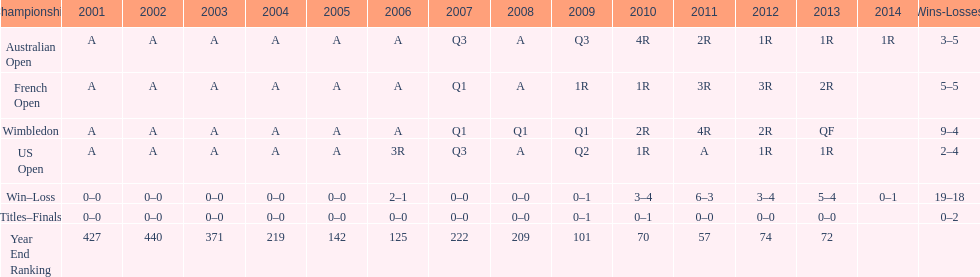What tournament has 5-5 as it's "w-l" record? French Open. 